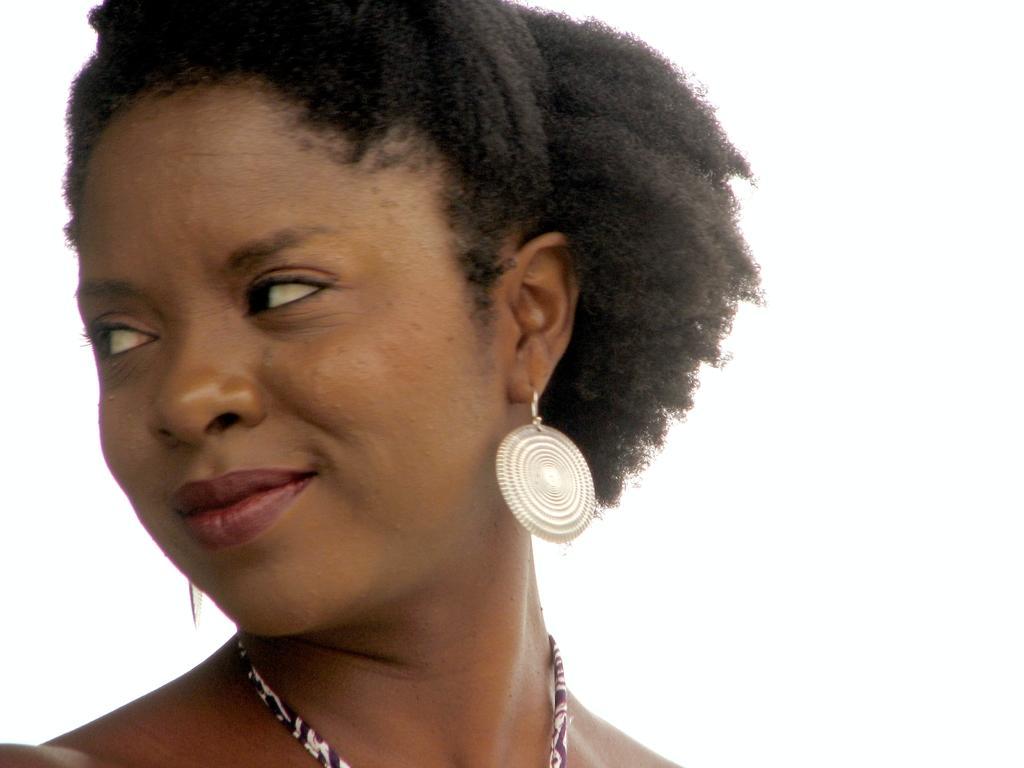In one or two sentences, can you explain what this image depicts? In this picture we can see a lady and wearing chain, earrings. 